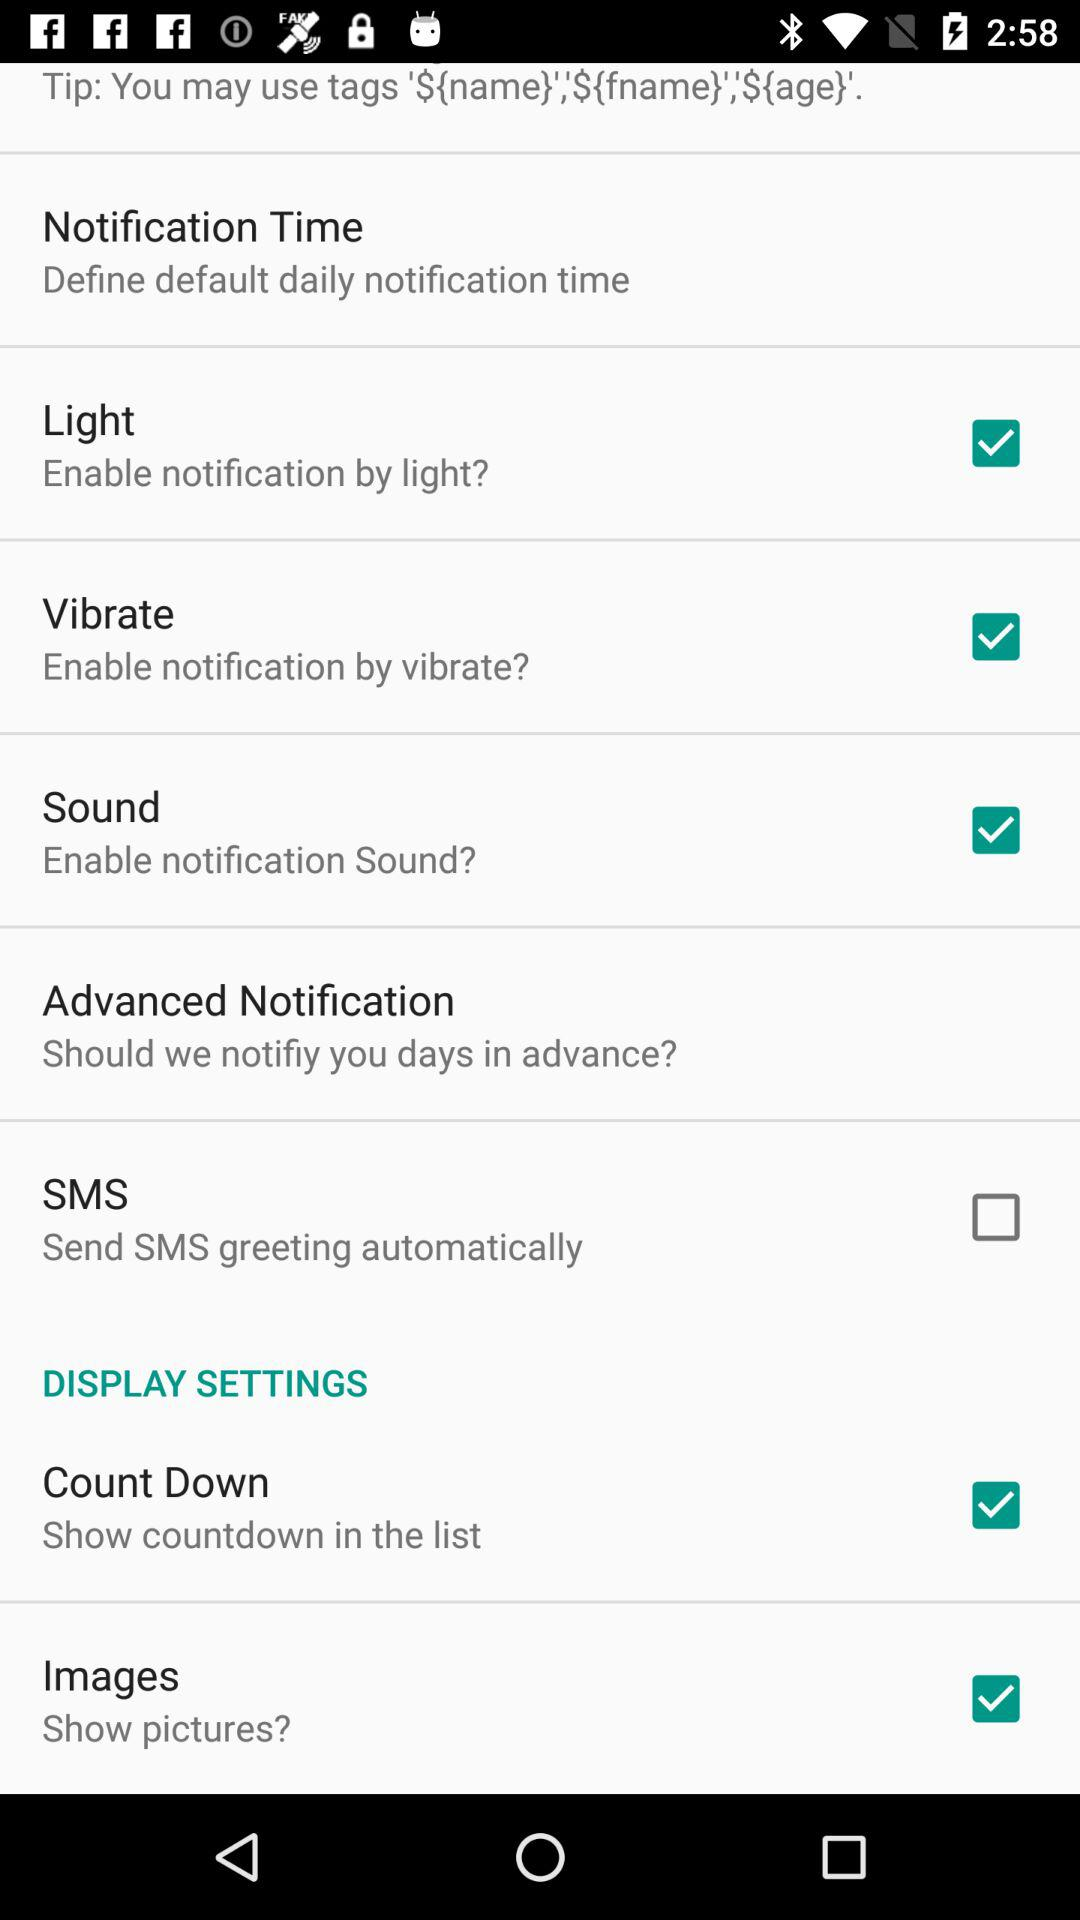What is the status of images? The status is on. 